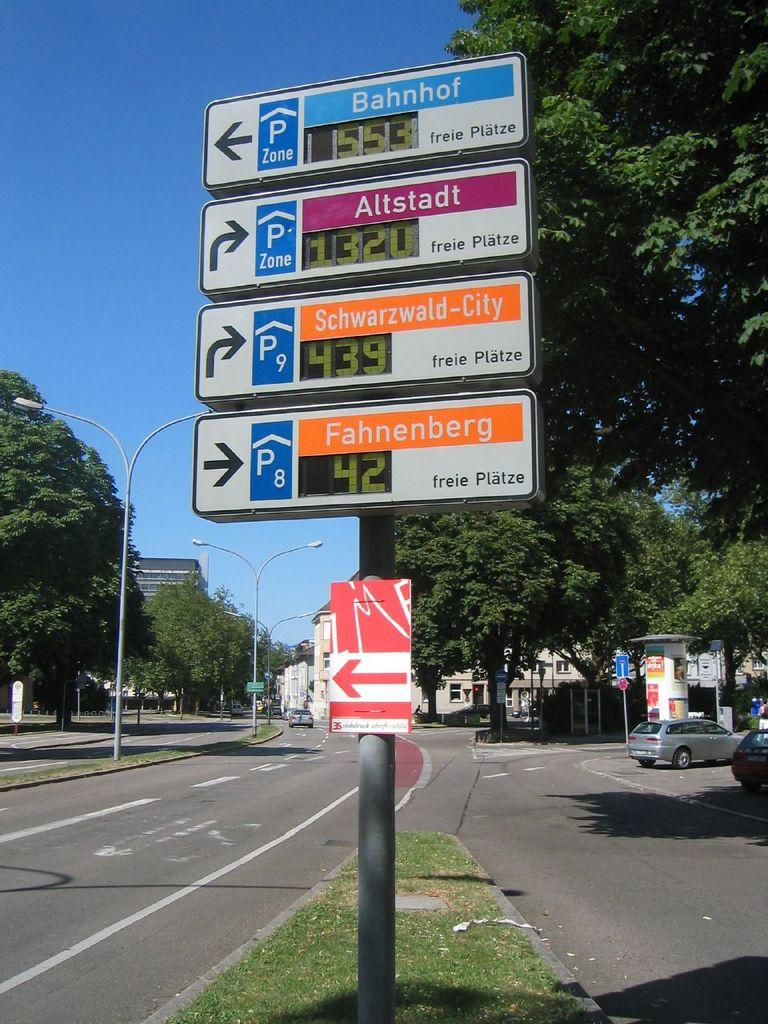Provide a one-sentence caption for the provided image. Directional signs show Bahnhof to the left and Altstadt to the right. 